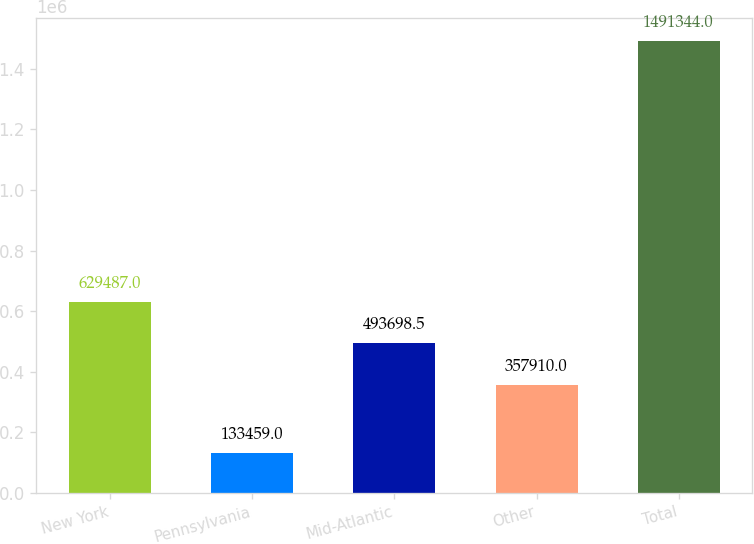<chart> <loc_0><loc_0><loc_500><loc_500><bar_chart><fcel>New York<fcel>Pennsylvania<fcel>Mid-Atlantic<fcel>Other<fcel>Total<nl><fcel>629487<fcel>133459<fcel>493698<fcel>357910<fcel>1.49134e+06<nl></chart> 